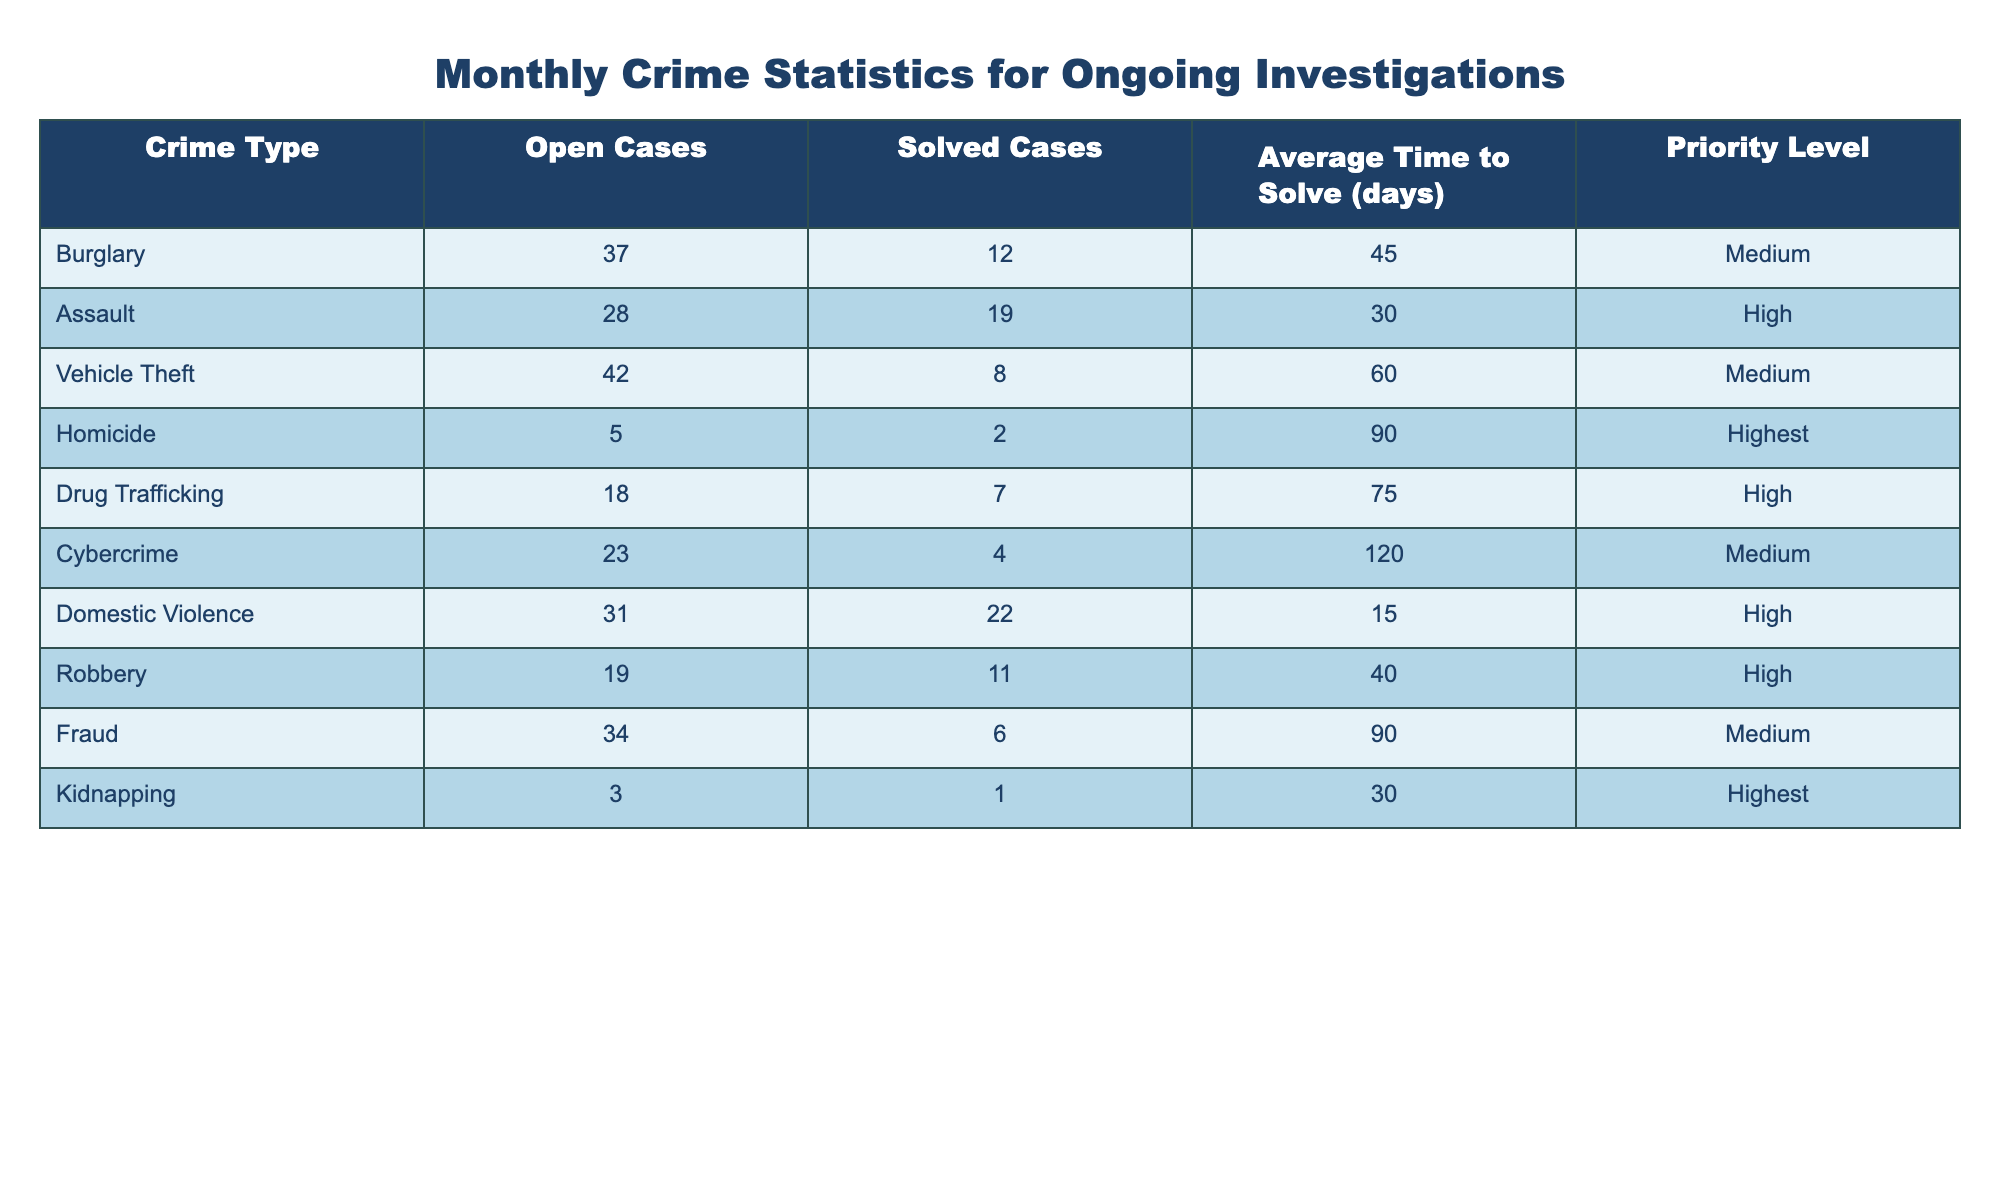What is the crime type with the highest number of open cases? By reviewing the "Open Cases" column, we see that Vehicle Theft has the highest number with 42 cases.
Answer: Vehicle Theft How many total solved cases are there across all crime types? To find the total solved cases, we add the values in the "Solved Cases" column: 12 + 19 + 8 + 2 + 7 + 4 + 22 + 11 + 6 + 1 = 92.
Answer: 92 Which crime type has the longest average time to solve? Looking at the "Average Time to Solve (days)" column, Cybercrime has the longest time with 120 days.
Answer: Cybercrime Is it true that Domestic Violence has more solved cases than Drug Trafficking? By comparing the "Solved Cases" values, Domestic Violence has 22 solved cases while Drug Trafficking has 7, confirming the statement is true.
Answer: Yes What is the average number of open cases for crime types with a 'High' priority level? The priority levels of High correspond to the following open cases: Assault (28), Drug Trafficking (18), Domestic Violence (31), Robbery (19). The average is calculated as (28 + 18 + 31 + 19) / 4 = 24.
Answer: 24 Which crime type has the least number of open cases? Inspecting the "Open Cases" column, we find that Kidnapping has the least with only 3 open cases.
Answer: Kidnapping If we combine the solved cases from Burglary and Fraud, how many cases does that give us? Adding the solved cases from Burglary (12) and Fraud (6), we get 12 + 6 = 18 solved cases combined.
Answer: 18 What is the difference in average time to solve between Homicide and Vehicle Theft? The average time to solve for Homicide is 90 days and for Vehicle Theft is 60 days; hence, the difference is 90 - 60 = 30 days.
Answer: 30 days Which crime type has the highest priority level? Reviewing the "Priority Level" column, both Homicide and Kidnapping are marked as the highest, indicating that there are two crime types at the highest level.
Answer: Homicide and Kidnapping How many crime types have an average time to solve of less than 50 days? From the "Average Time to Solve (days)" column, we find the following crime types with less than 50 days: Assault (30), Domestic Violence (15), and Robbery (40), totaling 3 crime types.
Answer: 3 